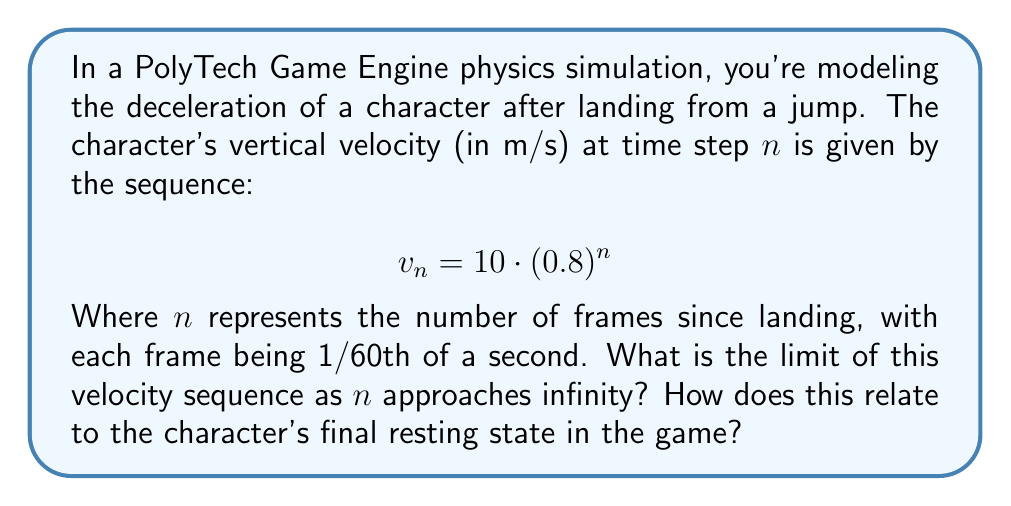Solve this math problem. To solve this problem, we need to analyze the limit of the given sequence as $n$ approaches infinity. Let's break it down step-by-step:

1) The general form of our sequence is:
   $$v_n = 10 \cdot (0.8)^n$$

2) To find the limit as $n$ approaches infinity, we can use the properties of exponential functions:
   $$\lim_{n \to \infty} v_n = \lim_{n \to \infty} 10 \cdot (0.8)^n$$

3) We can separate the constant:
   $$\lim_{n \to \infty} v_n = 10 \cdot \lim_{n \to \infty} (0.8)^n$$

4) Now, let's consider the behavior of $(0.8)^n$ as $n$ approaches infinity:
   - 0.8 is a positive number less than 1
   - As $n$ increases, $(0.8)^n$ will get smaller and smaller

5) In fact, for any real number $r$ where $0 < r < 1$:
   $$\lim_{n \to \infty} r^n = 0$$

6) Applying this to our problem:
   $$\lim_{n \to \infty} (0.8)^n = 0$$

7) Therefore:
   $$\lim_{n \to \infty} v_n = 10 \cdot 0 = 0$$

In the context of the PolyTech Game Engine physics simulation, this means that the character's vertical velocity will approach zero as time goes on. This aligns with the expected behavior in a game where a character should come to rest after landing from a jump. The exponential decay models a smooth deceleration that asymptotically approaches zero velocity.
Answer: The limit of the velocity sequence as $n$ approaches infinity is 0 m/s, representing the character coming to a complete stop in the vertical direction after landing. 